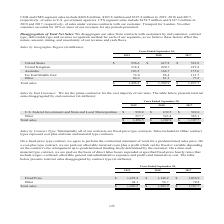According to Cubic's financial document, How does the company disaggregate its sales from contracts with customers? by end customer, contract type, deliverable type and revenue recognition method for each of our segments. The document states: "aggregate our sales from contracts with customers by end customer, contract type, deliverable type and revenue recognition method for each of our segm..." Also, What is the amount of total sales in 2017? According to the financial document, $1,107.7 (in millions). The relevant text states: "84.2 81.3 77.2 Total sales $ 1,496.5 $ 1,202.9 $ 1,107.7..." Also, What are the different geographic regions in the table? The document contains multiple relevant values: United States, United Kingdom, Australia, Far East/Middle East, Other. From the document: "Australia 163.5 166.7 175.6 Far East/Middle East 74.0 86.4 112.7 Australia 163.5 166.7 175.6 Far East/Middle East 74.0 86.4 112.7 Other 84.2 81.3 77.2..." Additionally, In which year was the amount of sales in Other the largest? According to the financial document, 2019. The relevant text states: "Years Ended September 30, 2019 2018 2017..." Also, can you calculate: What is the change in the amount of Other in 2019 from 2018? Based on the calculation: 84.2-81.3, the result is 2.9 (in millions). This is based on the information: "Other 84.2 81.3 77.2 Total sales $ 1,496.5 $ 1,202.9 $ 1,107.7 Other 84.2 81.3 77.2 Total sales $ 1,496.5 $ 1,202.9 $ 1,107.7..." The key data points involved are: 81.3, 84.2. Also, can you calculate: What is the percentage change in the amount of Other in 2019 from 2018? To answer this question, I need to perform calculations using the financial data. The calculation is: (84.2-81.3)/81.3, which equals 3.57 (percentage). This is based on the information: "Other 84.2 81.3 77.2 Total sales $ 1,496.5 $ 1,202.9 $ 1,107.7 Other 84.2 81.3 77.2 Total sales $ 1,496.5 $ 1,202.9 $ 1,107.7..." The key data points involved are: 81.3, 84.2. 